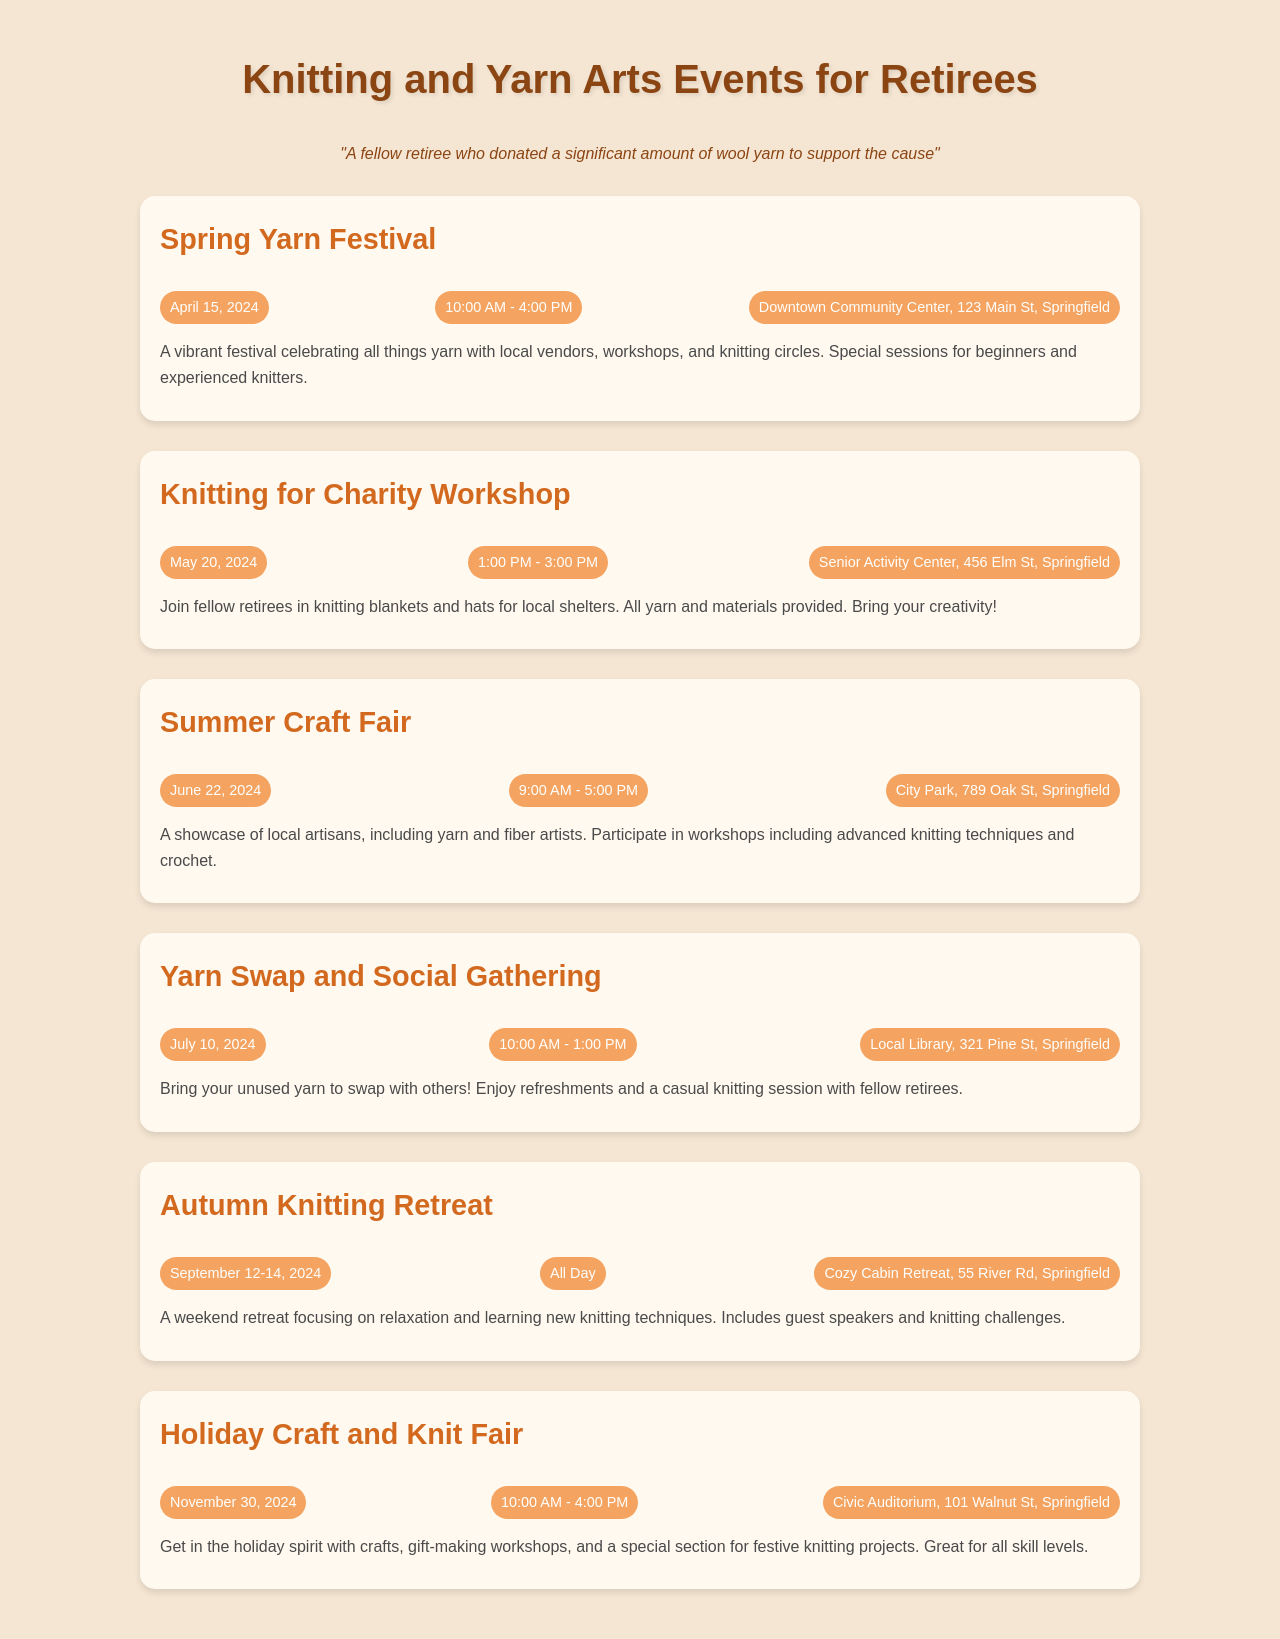What is the date of the Spring Yarn Festival? The date of the Spring Yarn Festival is mentioned as April 15, 2024.
Answer: April 15, 2024 What is the time for the Knitting for Charity Workshop? The time for the Knitting for Charity Workshop is listed as 1:00 PM - 3:00 PM.
Answer: 1:00 PM - 3:00 PM Where is the Summer Craft Fair located? The Summer Craft Fair is located at City Park, 789 Oak St, Springfield.
Answer: City Park, 789 Oak St, Springfield Which event spans multiple days? The event that spans multiple days is the Autumn Knitting Retreat, scheduled for September 12-14, 2024.
Answer: Autumn Knitting Retreat What type of gathering is the Yarn Swap and Social Gathering? The Yarn Swap and Social Gathering is a casual event where participants bring unused yarn to swap.
Answer: Casual event What is the focus of the Holiday Craft and Knit Fair? The focus of the Holiday Craft and Knit Fair is on crafts, gift-making workshops, and festive knitting projects.
Answer: Crafts, gift-making workshops, festive knitting projects 